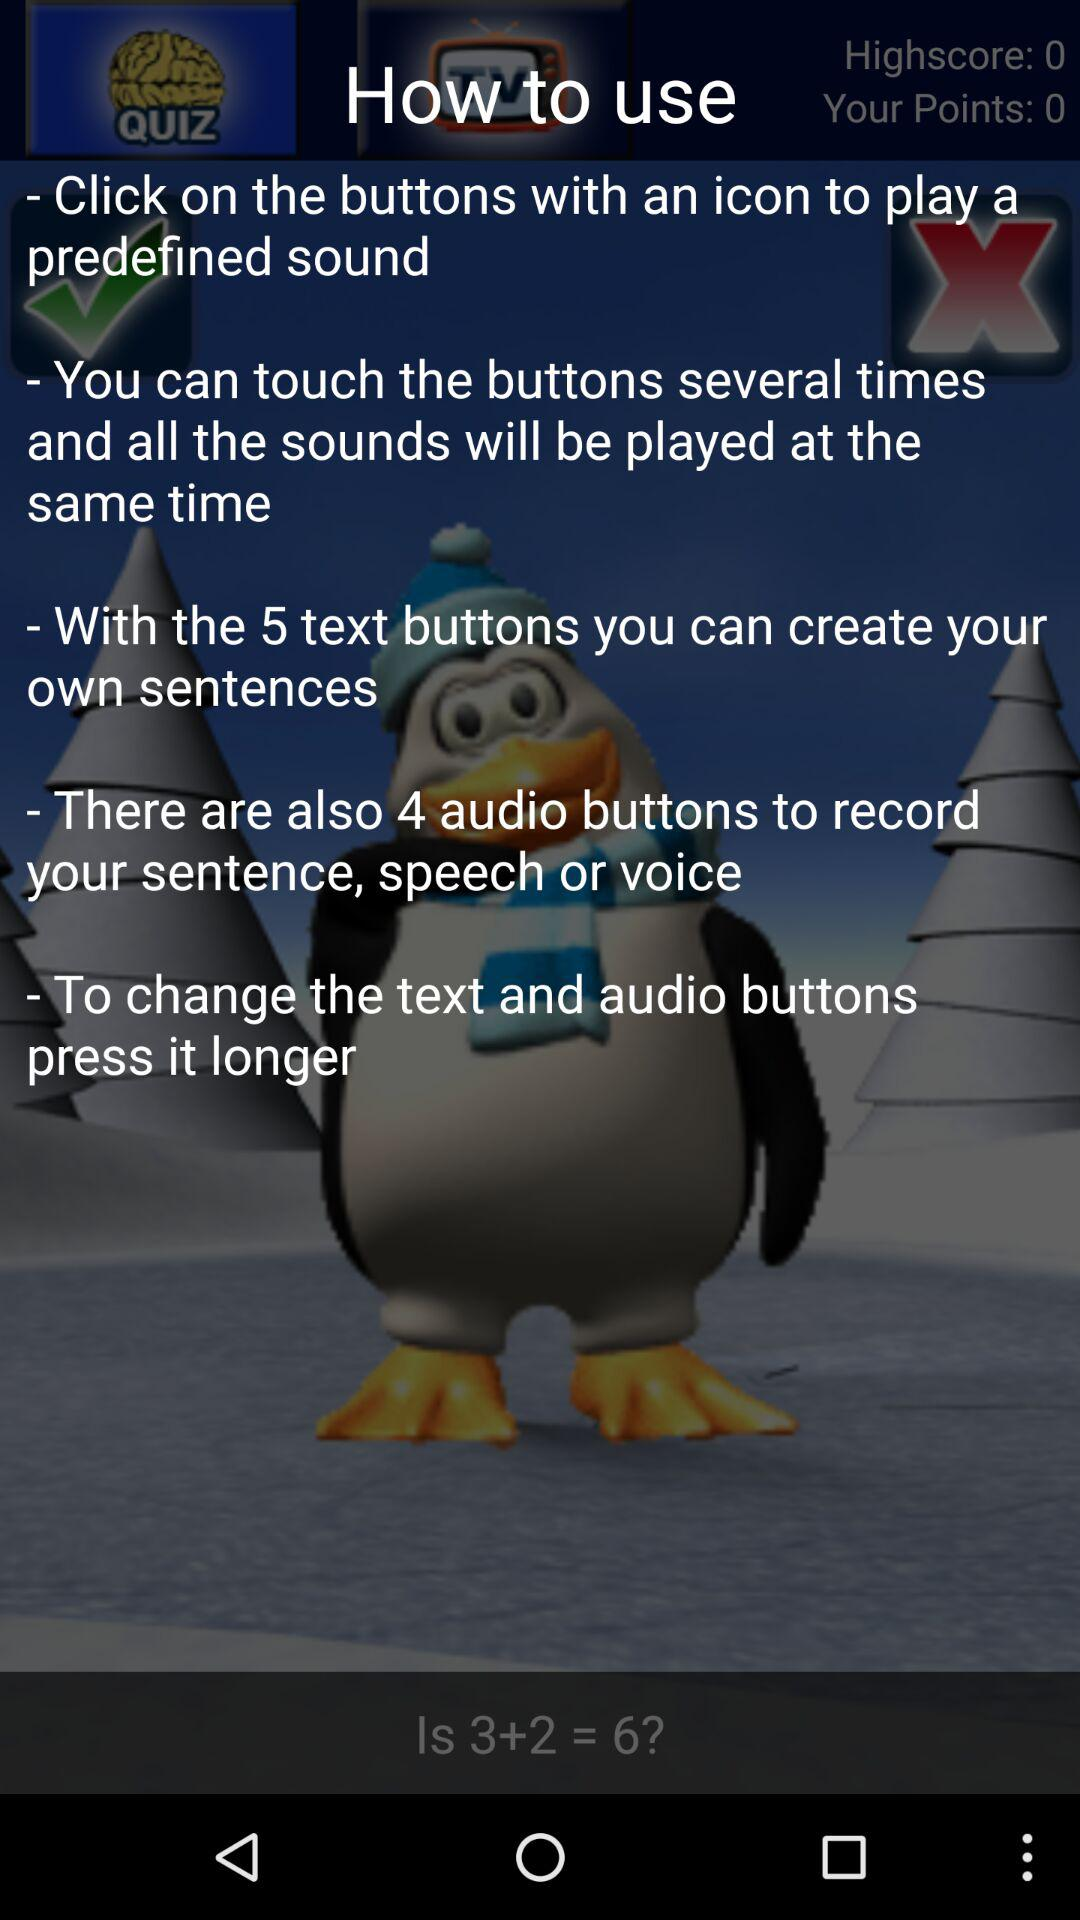Which icon is clicked?
When the provided information is insufficient, respond with <no answer>. <no answer> 